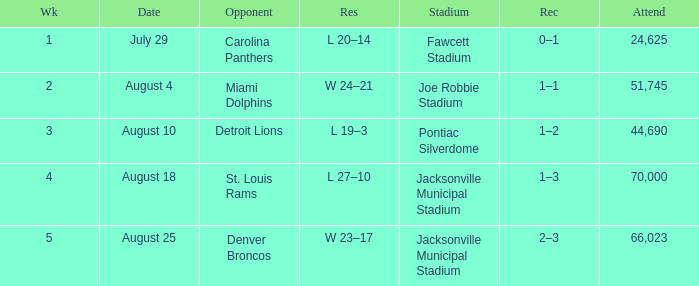WHEN has a Opponent of miami dolphins? August 4. 